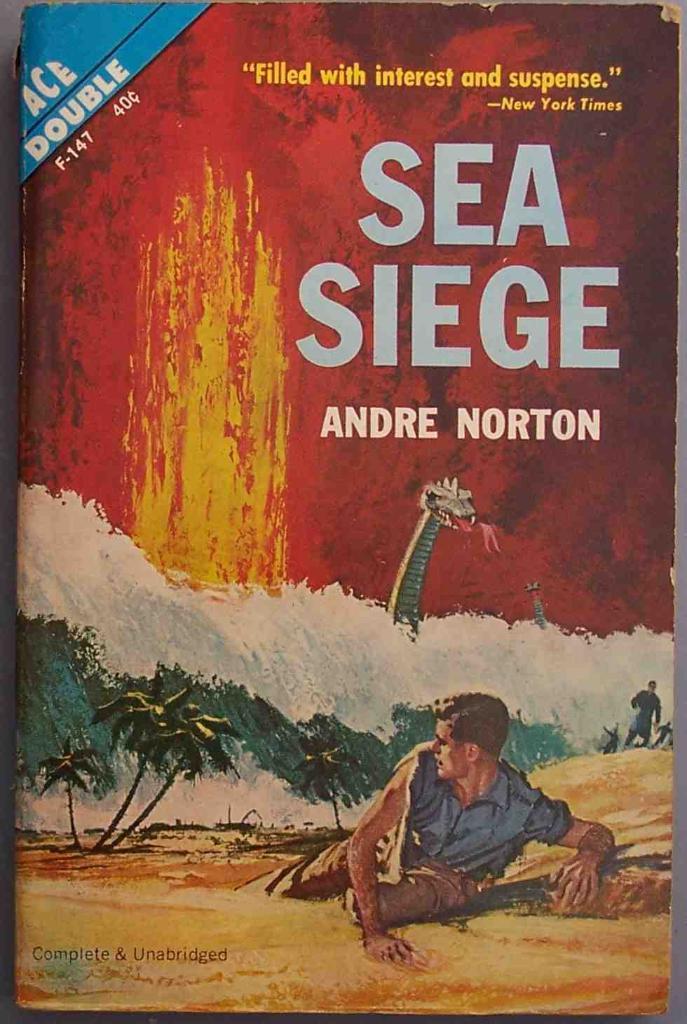What is the title of the novel?
Keep it short and to the point. Sea siege. 